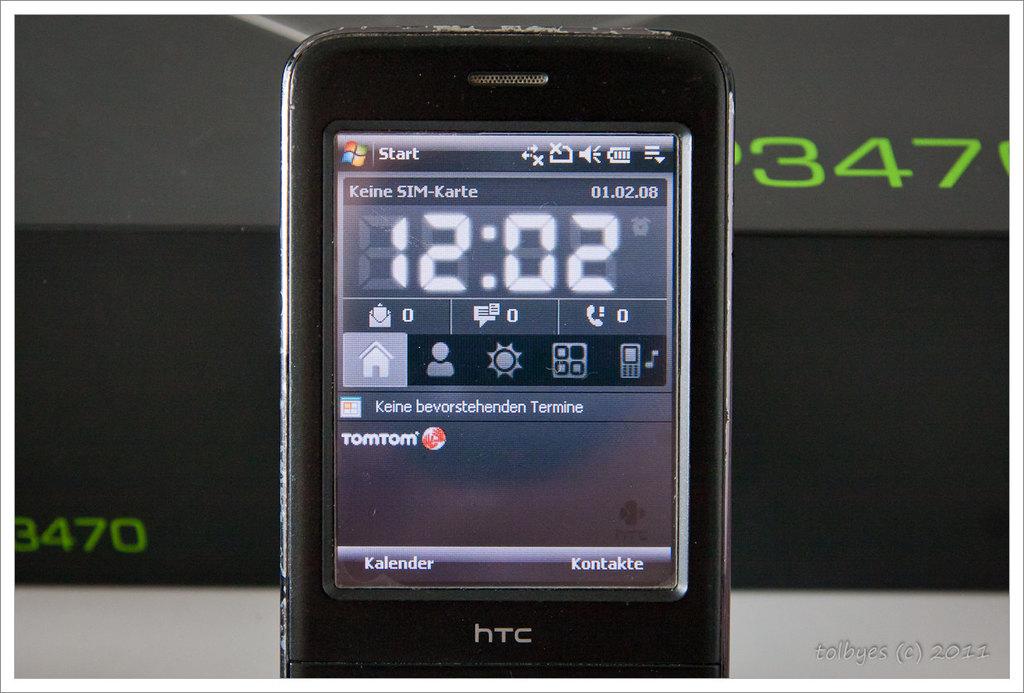What time is seen on the phone?
Ensure brevity in your answer.  12:02. What brand is this device?
Your response must be concise. Htc. 